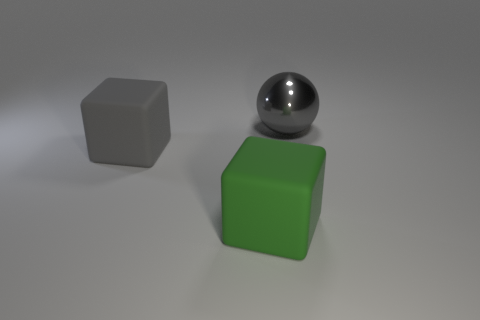Are there any green cubes that have the same size as the gray rubber block?
Offer a terse response. Yes. There is a gray thing that is right of the green cube; what material is it?
Ensure brevity in your answer.  Metal. Is the gray object that is on the left side of the big gray sphere made of the same material as the large sphere?
Provide a succinct answer. No. Is there a cube?
Offer a very short reply. Yes. What is the color of the other block that is the same material as the big gray cube?
Provide a succinct answer. Green. There is a big object that is to the right of the rubber cube in front of the gray object on the left side of the gray ball; what is its color?
Offer a terse response. Gray. Is the size of the gray metallic sphere the same as the cube that is left of the big green matte cube?
Offer a terse response. Yes. How many objects are either big objects behind the large gray block or big objects that are in front of the large gray matte object?
Offer a terse response. 2. The gray matte thing that is the same size as the gray sphere is what shape?
Your response must be concise. Cube. What is the shape of the rubber thing that is in front of the big gray thing left of the large gray object that is on the right side of the green matte object?
Give a very brief answer. Cube. 